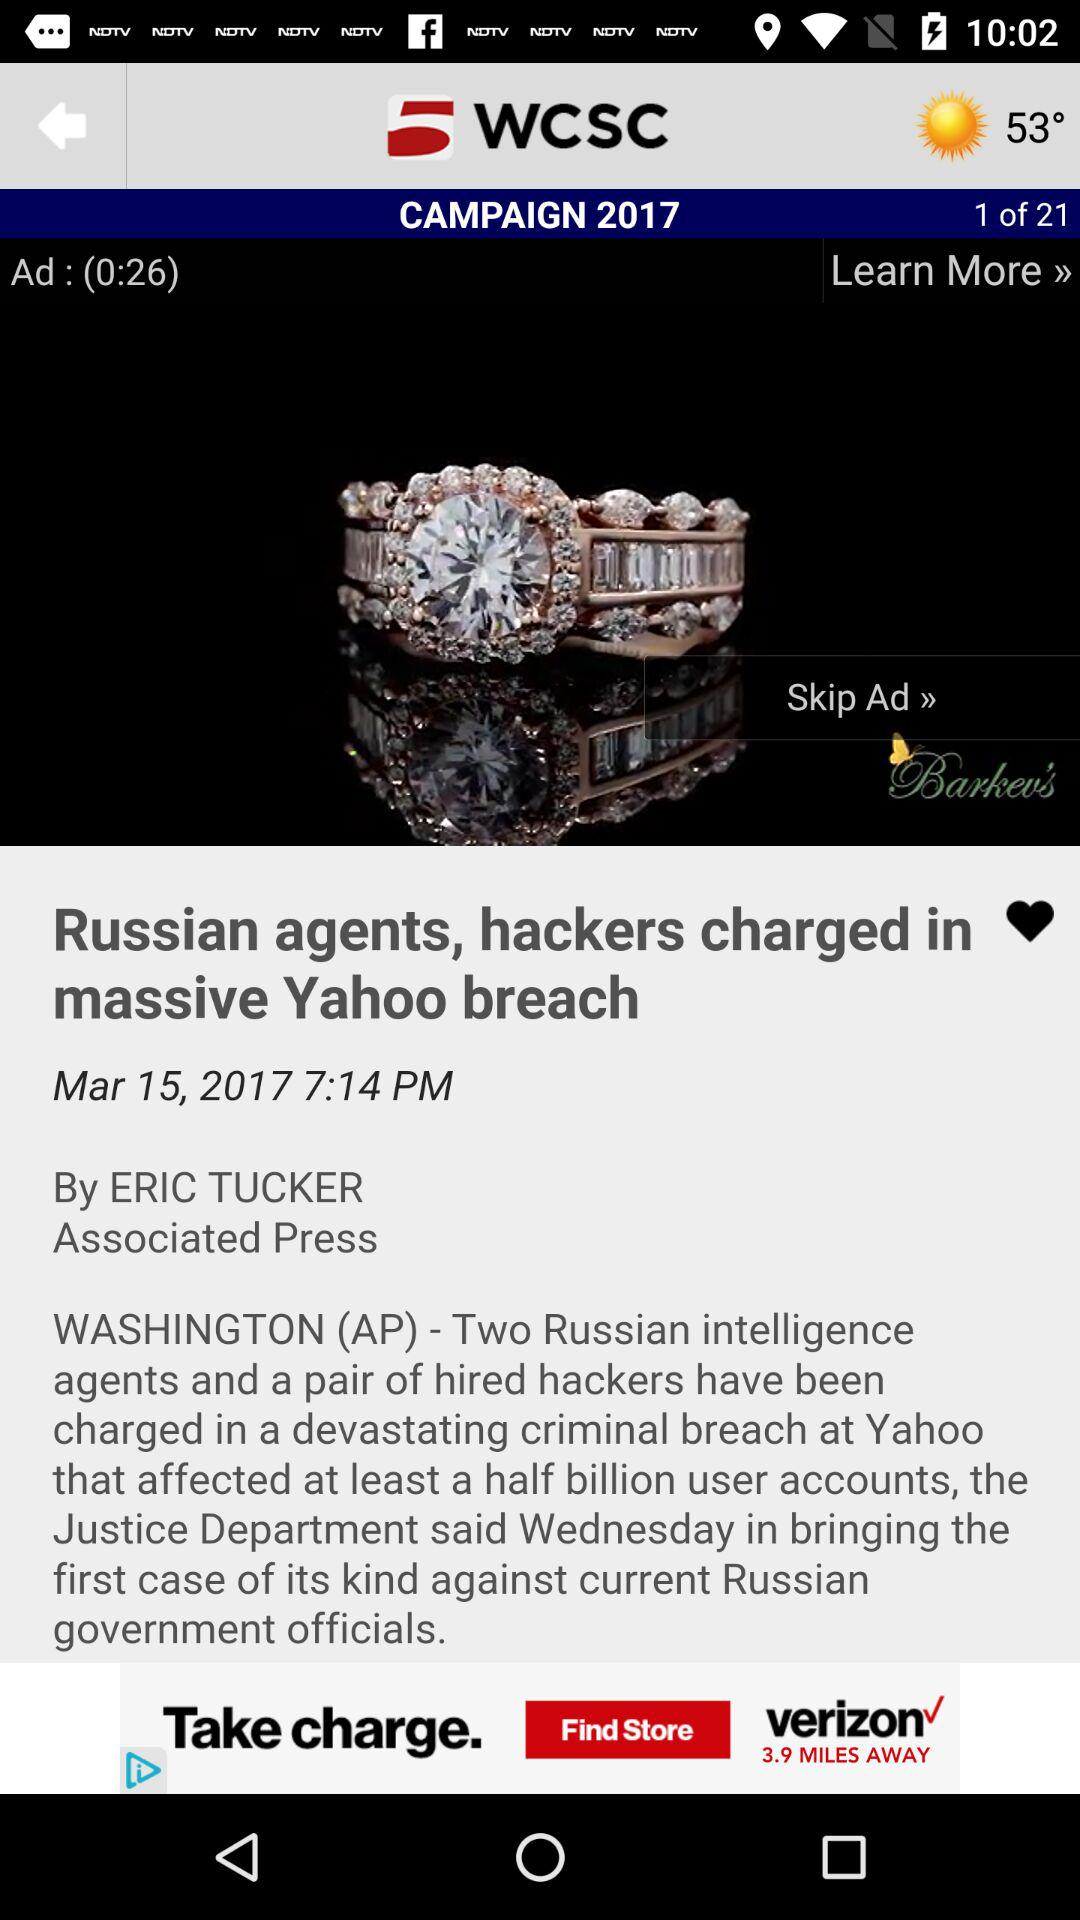What is the publication date of the "Russian agents, hackers charged in massive Yahoo breach"? The publication date is March 15, 2017. 